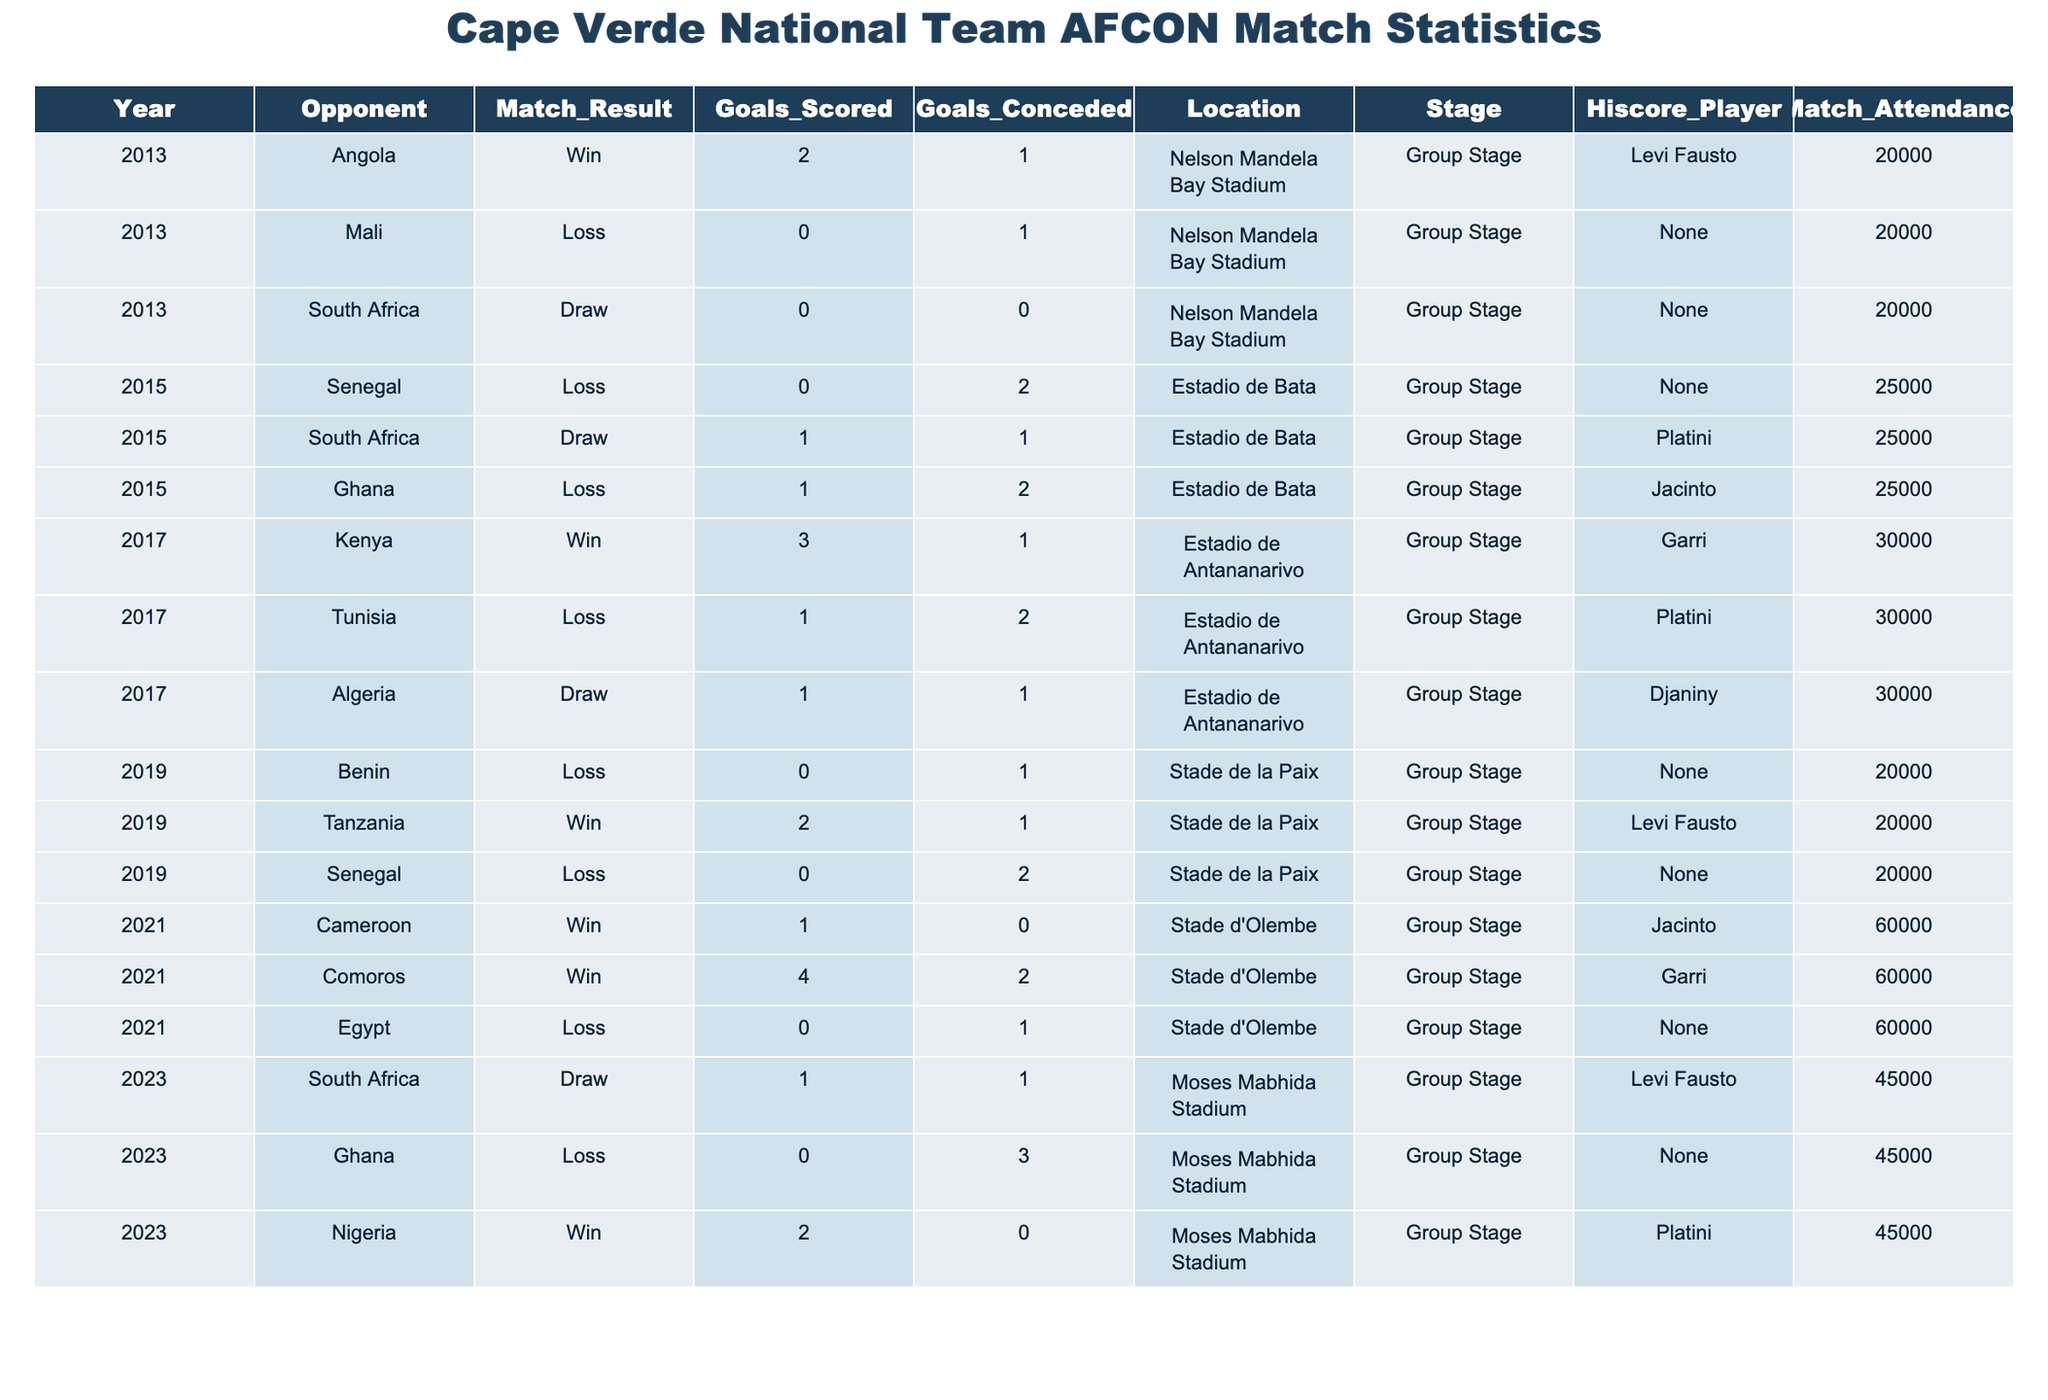What was Cape Verde's overall match result against Angola in 2013? Cape Verde won the match against Angola in 2013, as indicated in the "Match_Result" column for that year and opponent.
Answer: Win How many goals did Cape Verde score in total during the 2019 AFCON tournament? Cape Verde scored 2 goals against Tanzania and 0 against both Benin and Senegal, giving a total of 2 + 0 + 0 = 2 goals in the 2019 tournament.
Answer: 2 Which player was the top scorer for Cape Verde in their match against Comoros in 2021? The "Hiscore_Player" for the match against Comoros in 2021 is Garri, indicating he was the top scorer for that specific match.
Answer: Garri How many matches did Cape Verde draw during the AFCON history presented in the table? Cape Verde had 4 draws in total: 3 in 2013, 1 in 2015, 1 in 2017, and 1 in 2021, totaling 4 draws.
Answer: 4 What was Cape Verde's highest goal margin in a win during the AFCON history shown? The highest goal margin in a win is 2 goals, which occurred in the 2021 match against Comoros where Cape Verde won 4-2, achieving a margin of 2 goals.
Answer: 2 goals Did Cape Verde manage to score in all their matches in 2021? No, Cape Verde did not score in their match against Egypt in 2021, which is evident by the "Goals_Scored" column showing 0 for that match.
Answer: No What was the attendance for Cape Verde's draw match against South Africa in 2023? The attendance for the match against South Africa in 2023 was 45,000 as provided under the "Match_Attendance" column for that specific game.
Answer: 45000 What is the average number of goals scored by Cape Verde in matches they played during the 2017 AFCON? The total goals scored by Cape Verde in 2017 were 5 (3 against Kenya and 1 against Tunisia, 1 against Algeria), divided by 3 matches results in an average of 5/3 = 1.67.
Answer: 1.67 How many matches did Cape Verde lose in the AFCON history presented? Cape Verde lost a total of 6 matches, as enumerated in the "Match_Result" column where "Loss" is indicated.
Answer: 6 Which year did Cape Verde have the highest attendance for an AFCON match? The highest attendance for an AFCON match for Cape Verde was in 2021, with 60,000 spectators at two matches against Cameroon and Comoros.
Answer: 60000 